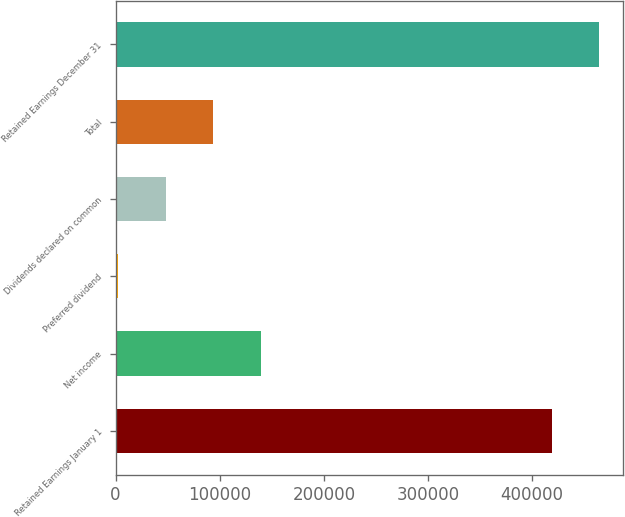Convert chart. <chart><loc_0><loc_0><loc_500><loc_500><bar_chart><fcel>Retained Earnings January 1<fcel>Net income<fcel>Preferred dividend<fcel>Dividends declared on common<fcel>Total<fcel>Retained Earnings December 31<nl><fcel>419001<fcel>139349<fcel>2768<fcel>48295.1<fcel>93822.2<fcel>464528<nl></chart> 